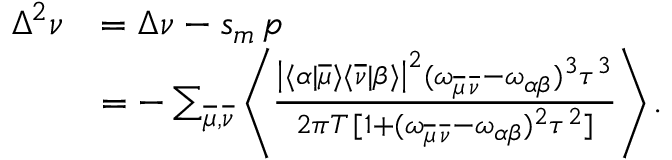<formula> <loc_0><loc_0><loc_500><loc_500>\begin{array} { r l } { \Delta ^ { 2 } \nu } & { = \Delta \nu - s _ { m } \, p } \\ & { = - \sum _ { \overline { \mu } , \overline { \nu } } \left \langle \frac { \left | \langle \alpha | \overline { \mu } \rangle \langle \overline { \nu } | \beta \rangle \right | ^ { 2 } ( \omega _ { \overline { \mu } \, \overline { \nu } } - \omega _ { \alpha \beta } ) ^ { 3 } \tau ^ { 3 } } { 2 \pi T \, [ 1 + ( \omega _ { \overline { \mu } \, \overline { \nu } } - \omega _ { \alpha \beta } ) ^ { 2 } \tau ^ { 2 } ] } \right \rangle . } \end{array}</formula> 